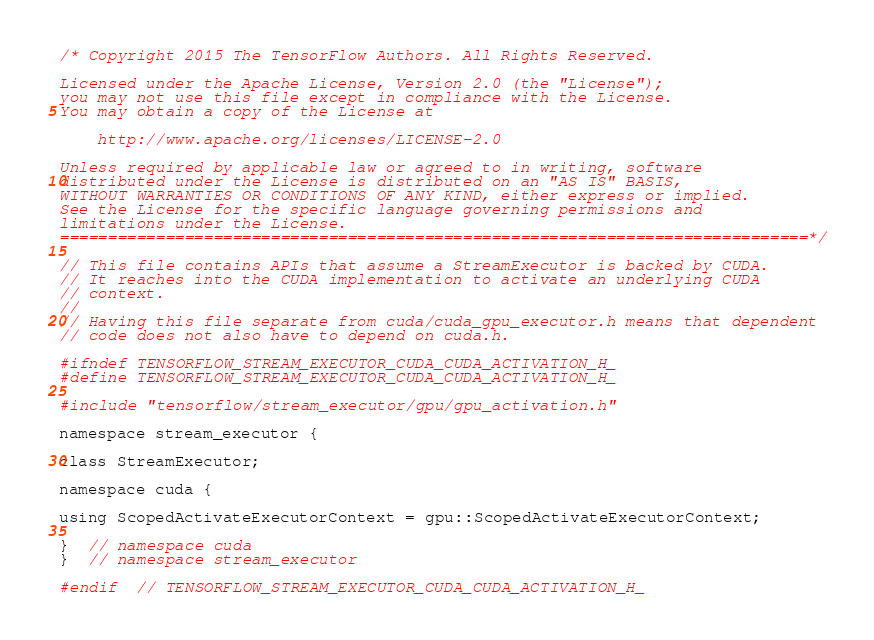<code> <loc_0><loc_0><loc_500><loc_500><_C_>/* Copyright 2015 The TensorFlow Authors. All Rights Reserved.

Licensed under the Apache License, Version 2.0 (the "License");
you may not use this file except in compliance with the License.
You may obtain a copy of the License at

    http://www.apache.org/licenses/LICENSE-2.0

Unless required by applicable law or agreed to in writing, software
distributed under the License is distributed on an "AS IS" BASIS,
WITHOUT WARRANTIES OR CONDITIONS OF ANY KIND, either express or implied.
See the License for the specific language governing permissions and
limitations under the License.
==============================================================================*/

// This file contains APIs that assume a StreamExecutor is backed by CUDA.
// It reaches into the CUDA implementation to activate an underlying CUDA
// context.
//
// Having this file separate from cuda/cuda_gpu_executor.h means that dependent
// code does not also have to depend on cuda.h.

#ifndef TENSORFLOW_STREAM_EXECUTOR_CUDA_CUDA_ACTIVATION_H_
#define TENSORFLOW_STREAM_EXECUTOR_CUDA_CUDA_ACTIVATION_H_

#include "tensorflow/stream_executor/gpu/gpu_activation.h"

namespace stream_executor {

class StreamExecutor;

namespace cuda {

using ScopedActivateExecutorContext = gpu::ScopedActivateExecutorContext;

}  // namespace cuda
}  // namespace stream_executor

#endif  // TENSORFLOW_STREAM_EXECUTOR_CUDA_CUDA_ACTIVATION_H_
</code> 